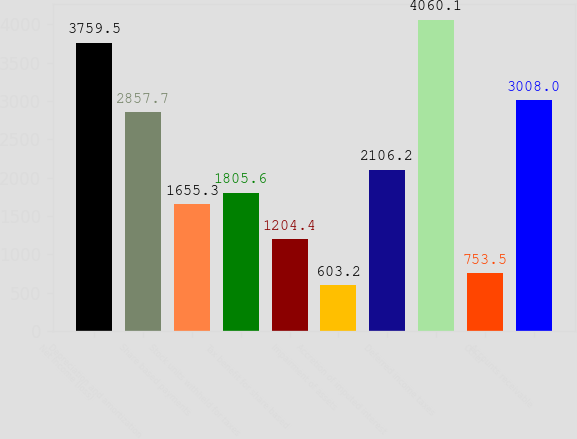<chart> <loc_0><loc_0><loc_500><loc_500><bar_chart><fcel>Net income (loss)<fcel>Depreciation and amortization<fcel>Share based payments<fcel>Stock units withheld for taxes<fcel>Tax benefit for share based<fcel>Impairment of assets<fcel>Accretion of imputed interest<fcel>Deferred income taxes<fcel>Other<fcel>Accounts receivable<nl><fcel>3759.5<fcel>2857.7<fcel>1655.3<fcel>1805.6<fcel>1204.4<fcel>603.2<fcel>2106.2<fcel>4060.1<fcel>753.5<fcel>3008<nl></chart> 